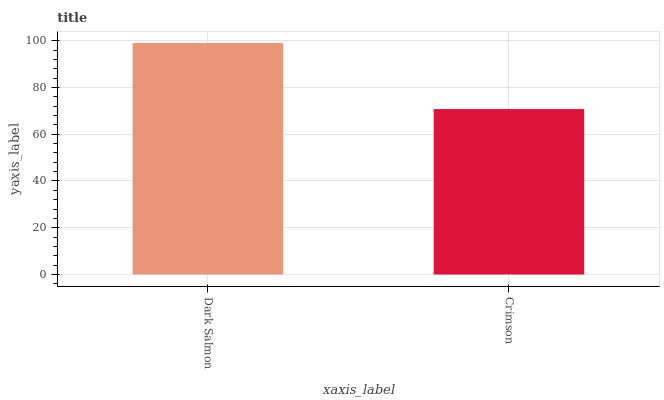Is Crimson the minimum?
Answer yes or no. Yes. Is Dark Salmon the maximum?
Answer yes or no. Yes. Is Crimson the maximum?
Answer yes or no. No. Is Dark Salmon greater than Crimson?
Answer yes or no. Yes. Is Crimson less than Dark Salmon?
Answer yes or no. Yes. Is Crimson greater than Dark Salmon?
Answer yes or no. No. Is Dark Salmon less than Crimson?
Answer yes or no. No. Is Dark Salmon the high median?
Answer yes or no. Yes. Is Crimson the low median?
Answer yes or no. Yes. Is Crimson the high median?
Answer yes or no. No. Is Dark Salmon the low median?
Answer yes or no. No. 